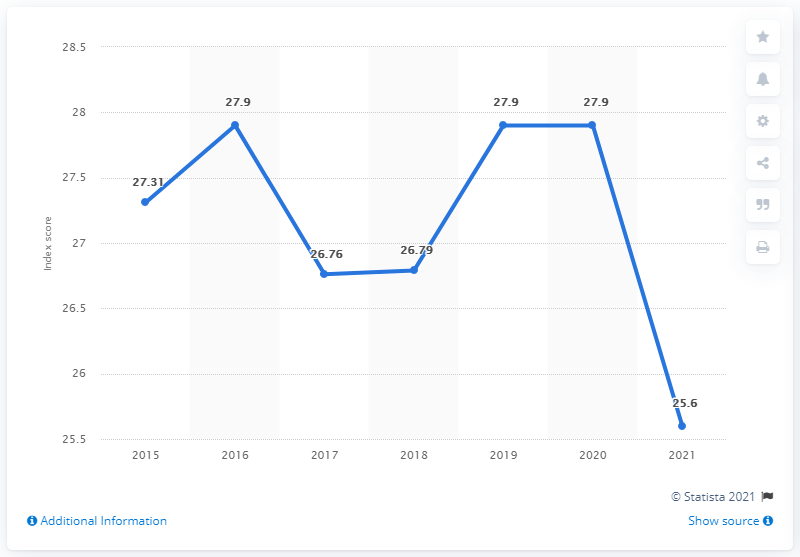What was the Dominican Republic's press freedom index a year earlier? Based on the displayed trend in the image, the Dominican Republic's press freedom index a year prior to the last data point (2021) with an index score of 25.6, would be the value recorded for 2020. The image shows a value of 27.9 for 2020, indicating a relative decline in press freedom compared to the previous year. 